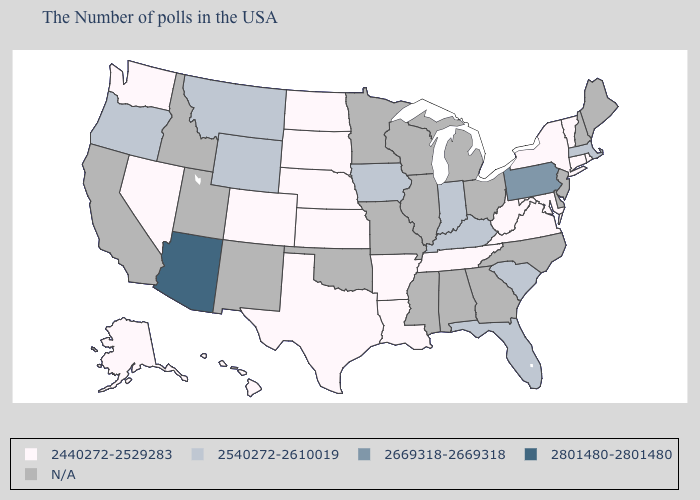What is the lowest value in the West?
Write a very short answer. 2440272-2529283. What is the lowest value in states that border Arizona?
Answer briefly. 2440272-2529283. Name the states that have a value in the range 2540272-2610019?
Be succinct. Massachusetts, South Carolina, Florida, Kentucky, Indiana, Iowa, Wyoming, Montana, Oregon. Is the legend a continuous bar?
Concise answer only. No. Does Pennsylvania have the highest value in the Northeast?
Be succinct. Yes. Which states have the highest value in the USA?
Give a very brief answer. Arizona. What is the value of Hawaii?
Short answer required. 2440272-2529283. Name the states that have a value in the range 2440272-2529283?
Be succinct. Rhode Island, Vermont, Connecticut, New York, Maryland, Virginia, West Virginia, Tennessee, Louisiana, Arkansas, Kansas, Nebraska, Texas, South Dakota, North Dakota, Colorado, Nevada, Washington, Alaska, Hawaii. Does Wyoming have the lowest value in the West?
Answer briefly. No. Name the states that have a value in the range 2440272-2529283?
Be succinct. Rhode Island, Vermont, Connecticut, New York, Maryland, Virginia, West Virginia, Tennessee, Louisiana, Arkansas, Kansas, Nebraska, Texas, South Dakota, North Dakota, Colorado, Nevada, Washington, Alaska, Hawaii. Name the states that have a value in the range 2669318-2669318?
Short answer required. Pennsylvania. Name the states that have a value in the range N/A?
Quick response, please. Maine, New Hampshire, New Jersey, Delaware, North Carolina, Ohio, Georgia, Michigan, Alabama, Wisconsin, Illinois, Mississippi, Missouri, Minnesota, Oklahoma, New Mexico, Utah, Idaho, California. Name the states that have a value in the range 2440272-2529283?
Quick response, please. Rhode Island, Vermont, Connecticut, New York, Maryland, Virginia, West Virginia, Tennessee, Louisiana, Arkansas, Kansas, Nebraska, Texas, South Dakota, North Dakota, Colorado, Nevada, Washington, Alaska, Hawaii. Which states hav the highest value in the South?
Write a very short answer. South Carolina, Florida, Kentucky. 